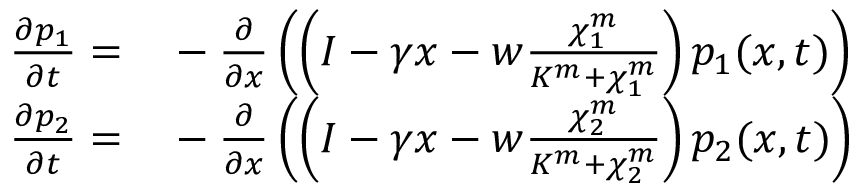Convert formula to latex. <formula><loc_0><loc_0><loc_500><loc_500>\begin{array} { r l } { \frac { \partial p _ { 1 } } { \partial t } = } & - \frac { \partial } { \partial x } \left ( \left ( I - \gamma x - w \frac { \chi _ { 1 } ^ { m } } { K ^ { m } + \chi _ { 1 } ^ { m } } \right ) p _ { 1 } ( x , t ) \right ) } \\ { \frac { \partial p _ { 2 } } { \partial t } = } & - \frac { \partial } { \partial x } \left ( \left ( I - \gamma x - w \frac { \chi _ { 2 } ^ { m } } { K ^ { m } + \chi _ { 2 } ^ { m } } \right ) p _ { 2 } ( x , t ) \right ) } \end{array}</formula> 